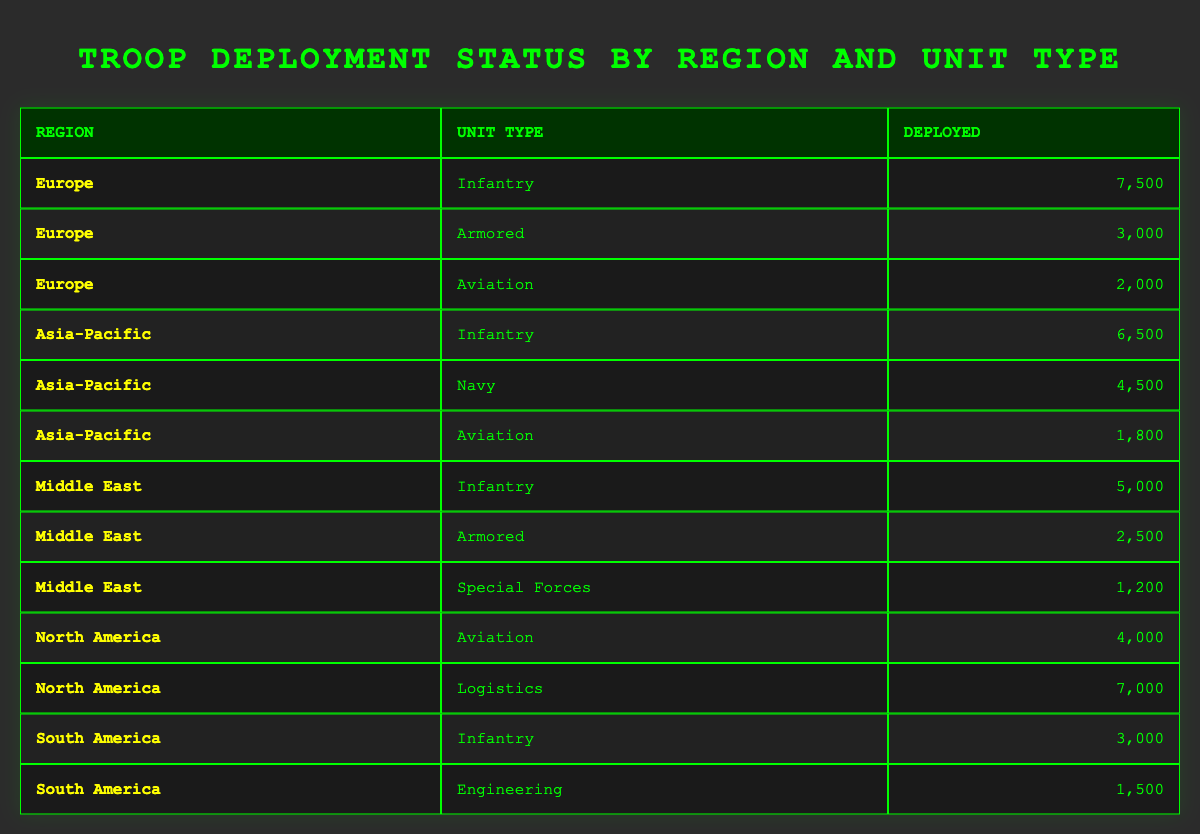What is the total number of troops deployed in the Europe region? In the Europe region, the deployed troops consist of Infantry (7,500), Armored (3,000), and Aviation (2,000). To find the total, we sum these values: 7,500 + 3,000 + 2,000 = 12,500.
Answer: 12,500 Which region has the highest number of deployed Infantry troops? By checking the table, the regions for Infantry troops are: Europe (7,500), Asia-Pacific (6,500), and Middle East (5,000). The highest is in Europe with 7,500.
Answer: Europe Are there any Armored units deployed in South America? Looking at the South America section, there are no entries for Armored units. The listed unit types are Infantry (3,000) and Engineering (1,500). Therefore, there are no Armored units in South America.
Answer: No What is the difference in the number of deployed Aviation troops between North America and Asia-Pacific? North America has 4,000 deployed Aviation troops, while Asia-Pacific has 1,800. The difference can be calculated as 4,000 - 1,800 = 2,200.
Answer: 2,200 What is the total number of deployed troops across all regions? We need to sum the deployed numbers from each region: Europe (12,500), Asia-Pacific (12,800), Middle East (8,700), North America (11,000), and South America (4,500). The total is calculated as 12,500 + 12,800 + 8,700 + 11,000 + 4,500 = 49,500.
Answer: 49,500 Is there a unit type where the number deployed is greater than 7,000? Reviewing the table, no unit types exceed 7,000. The maximum is 7,500 for Infantry in Europe. Thus, the answer is no.
Answer: No Which unit type has the least number of deployed troops? We compare all troop deployments: Infantry (7,500, 6,500, 5,000, 3,000), Armored (3,000, 2,500), Aviation (2,000, 1,800, 4,000), Navy (4,500), Special Forces (1,200), Logistics (7,000), Engineering (1,500). The least is Special Forces with 1,200.
Answer: Special Forces What unit type has the highest total deployment in the Asia-Pacific region? In Asia-Pacific, the deployed troops are: Infantry (6,500), Navy (4,500), and Aviation (1,800). The highest is Infantry with 6,500.
Answer: Infantry How many unit types are deployed in the Middle East? In the Middle East, there are three unit types listed: Infantry, Armored, and Special Forces. Therefore, there are three unit types.
Answer: 3 